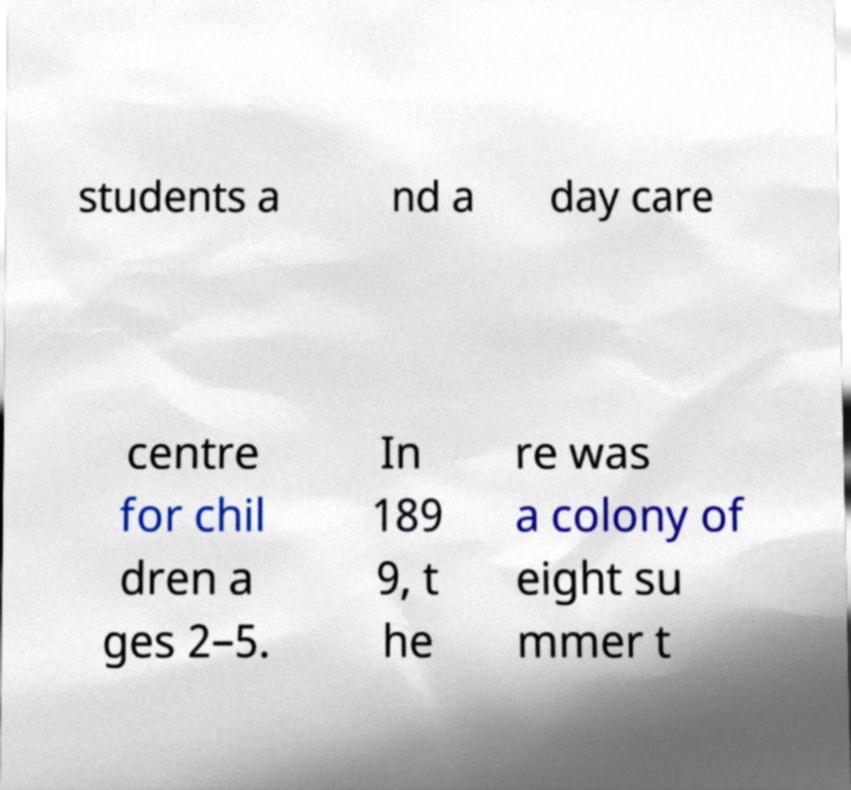What messages or text are displayed in this image? I need them in a readable, typed format. students a nd a day care centre for chil dren a ges 2–5. In 189 9, t he re was a colony of eight su mmer t 